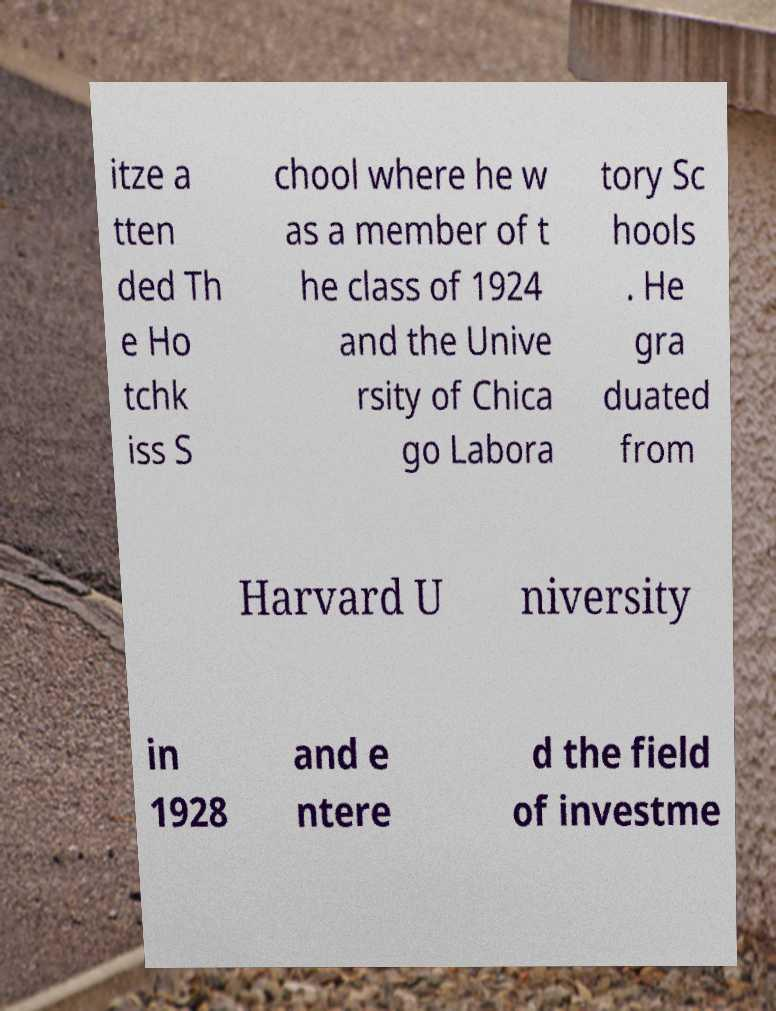I need the written content from this picture converted into text. Can you do that? itze a tten ded Th e Ho tchk iss S chool where he w as a member of t he class of 1924 and the Unive rsity of Chica go Labora tory Sc hools . He gra duated from Harvard U niversity in 1928 and e ntere d the field of investme 